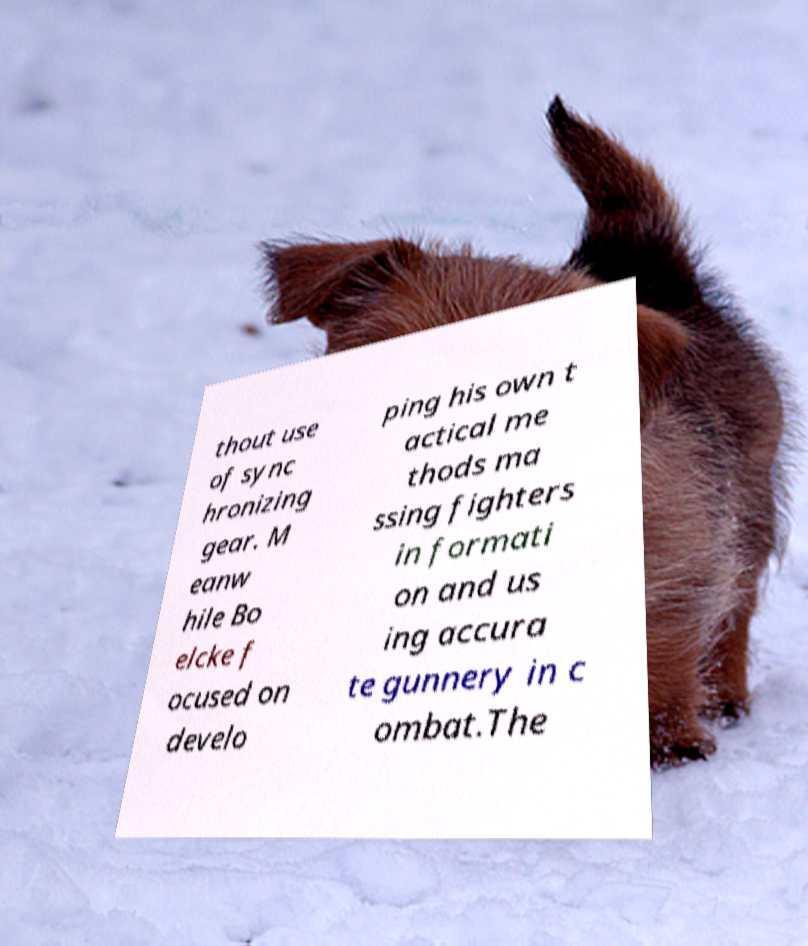Could you extract and type out the text from this image? thout use of sync hronizing gear. M eanw hile Bo elcke f ocused on develo ping his own t actical me thods ma ssing fighters in formati on and us ing accura te gunnery in c ombat.The 